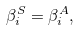<formula> <loc_0><loc_0><loc_500><loc_500>\beta _ { i } ^ { S } = \beta _ { i } ^ { A } ,</formula> 